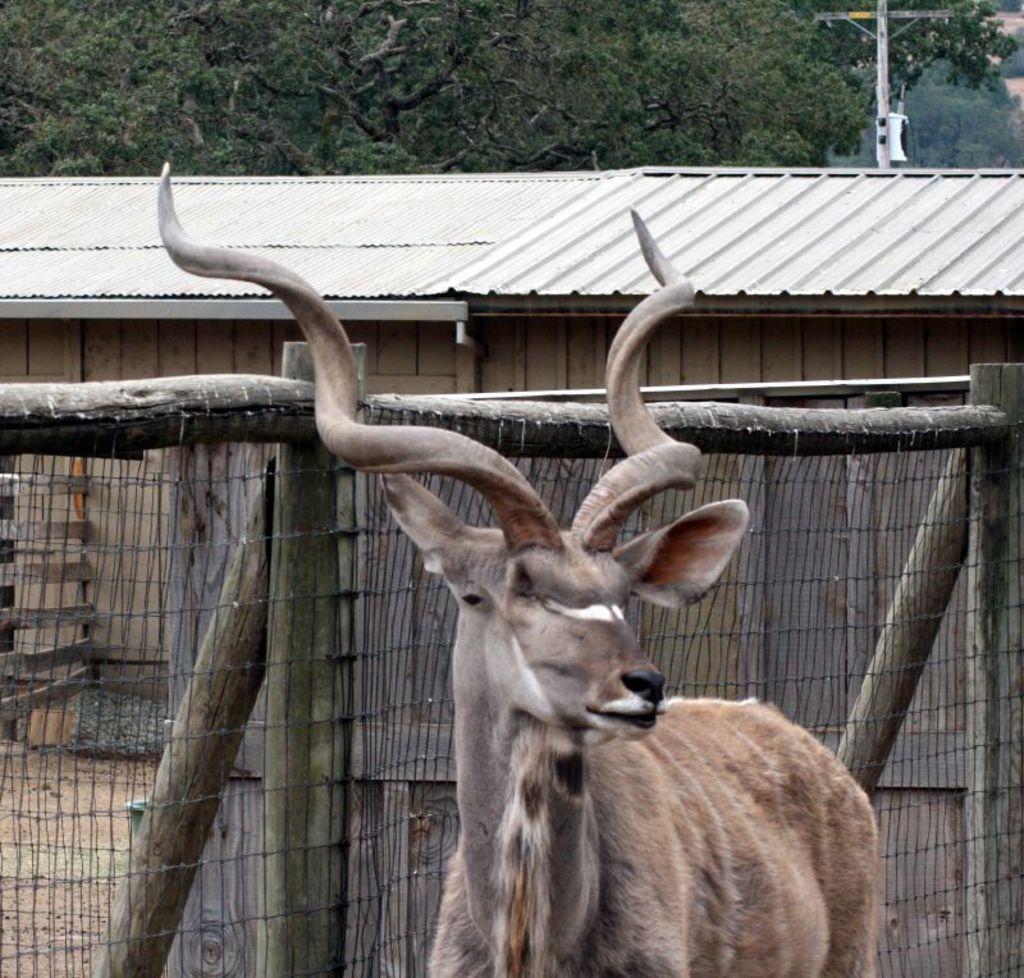Describe this image in one or two sentences. In this image we can see an animal. Behind the animal we can see a fencing and a house. At the top we can see a pole and a group of trees. 